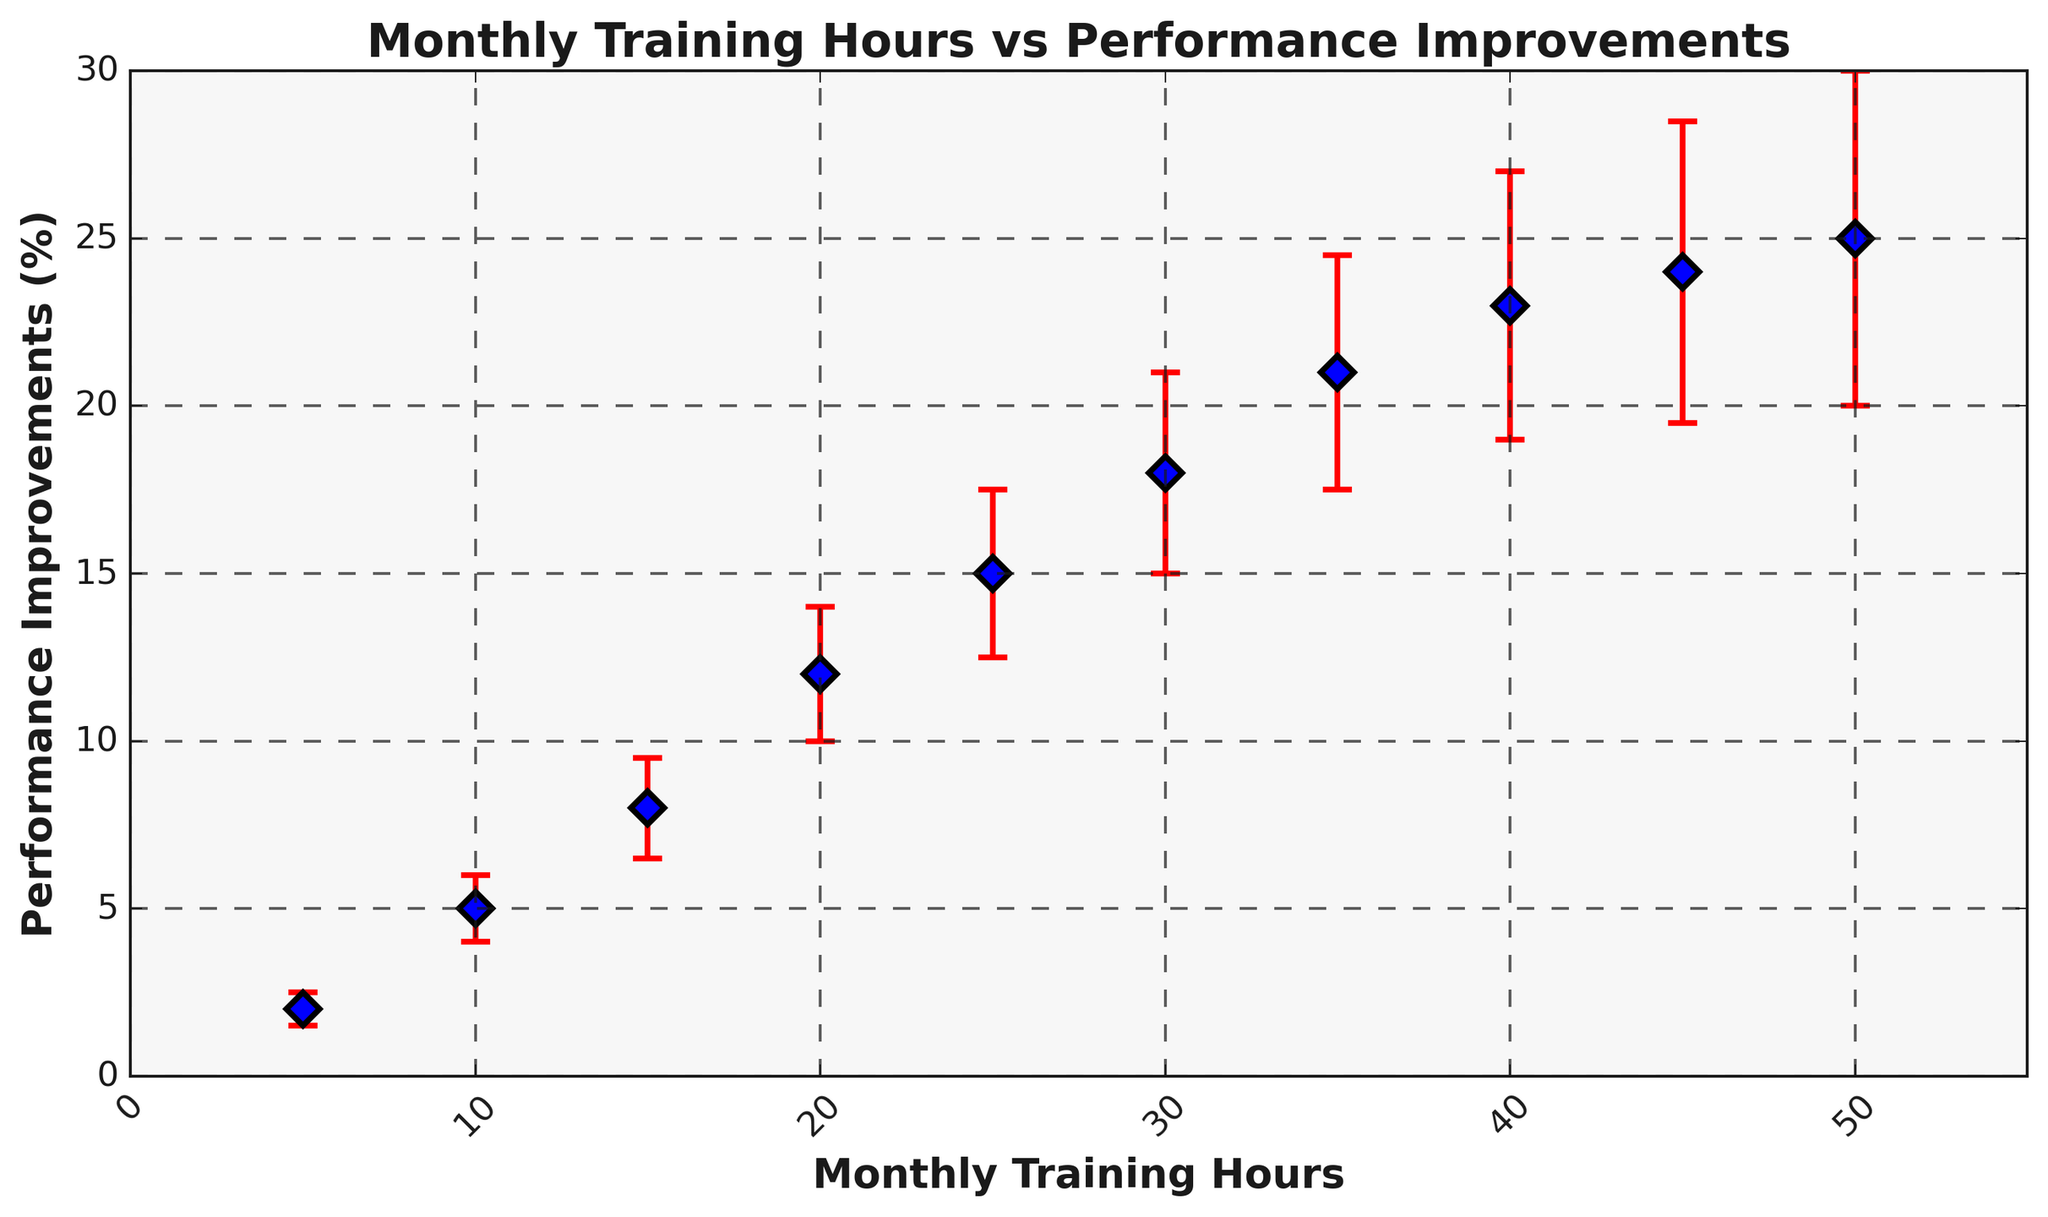what's the average performance improvement for 15 and 25 monthly training hours? For 15 training hours, the performance improvement is 8%. For 25 training hours, the performance improvement is 15%. The average is (8 + 15)/2 = 23/2 = 11.5%
Answer: 11.5% Which data point has the smallest error margin? By visually inspecting the error bars, the smallest error margin is for 5 monthly training hours, with an error margin of 0.5%.
Answer: 5 monthly training hours Are the error margins increasing or decreasing with the increase in training hours? By observing the error bars' lengths, they seem to be increasing gradually as the training hours increase.
Answer: Increasing What is the performance improvement for 35 monthly training hours? From the plot, find the performance improvement corresponding to 35 training hours, which is 21%.
Answer: 21% Is there a significant increase in performance improvements after 20 monthly training hours? By comparing the performance improvements, from 20 hours (12%) to 25 hours (15%) there is a 3% increase. From 25 hours onwards, the increase is consistent but the amounts are smaller per increment.
Answer: Yes, initially What's the difference in performance improvements between 30 and 50 monthly training hours? For 30 training hours, the performance improvement is 18%. For 50 training hours, it is 25%. The difference is 25 - 18 = 7%.
Answer: 7% What's the difference in error margins between 10 and 45 monthly training hours? For 10 training hours, the error margin is 1%. For 45 training hours, it is 4.5%. The difference is 4.5 - 1 = 3.5%.
Answer: 3.5% What color represents the error bars in the plot? By visually identifying the color, the error bars are represented in red.
Answer: Red What is the highest performance improvement percentage observed in the plot? The highest performance improvement percentage on the plot is 25% for 50 monthly training hours.
Answer: 25% 